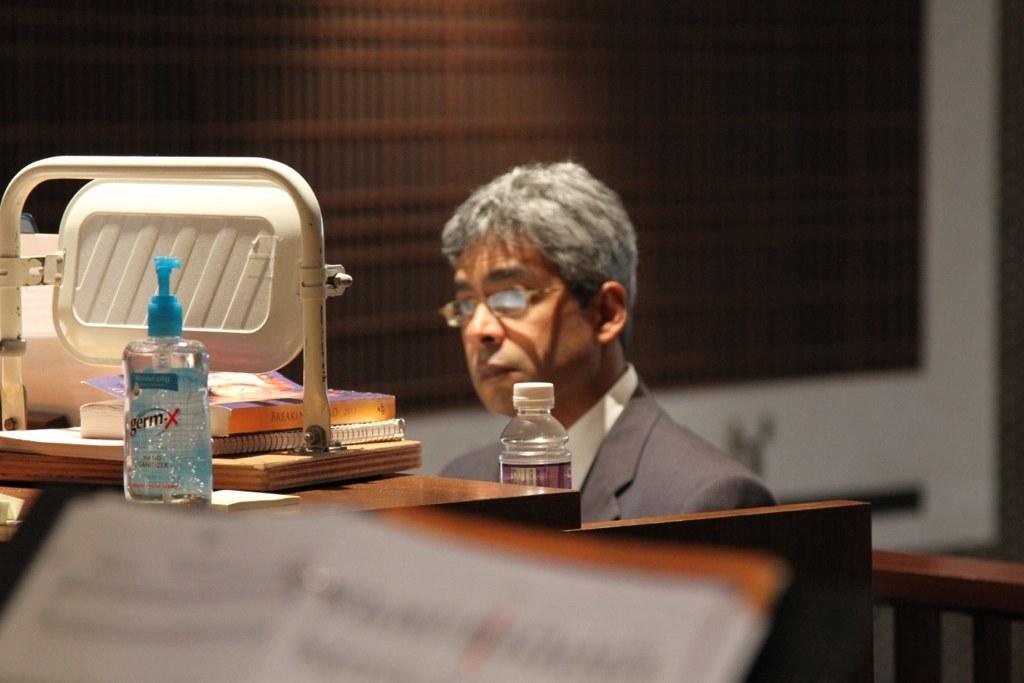What is the name of the bottle of hand sanitize?
Your answer should be compact. Germ x. 